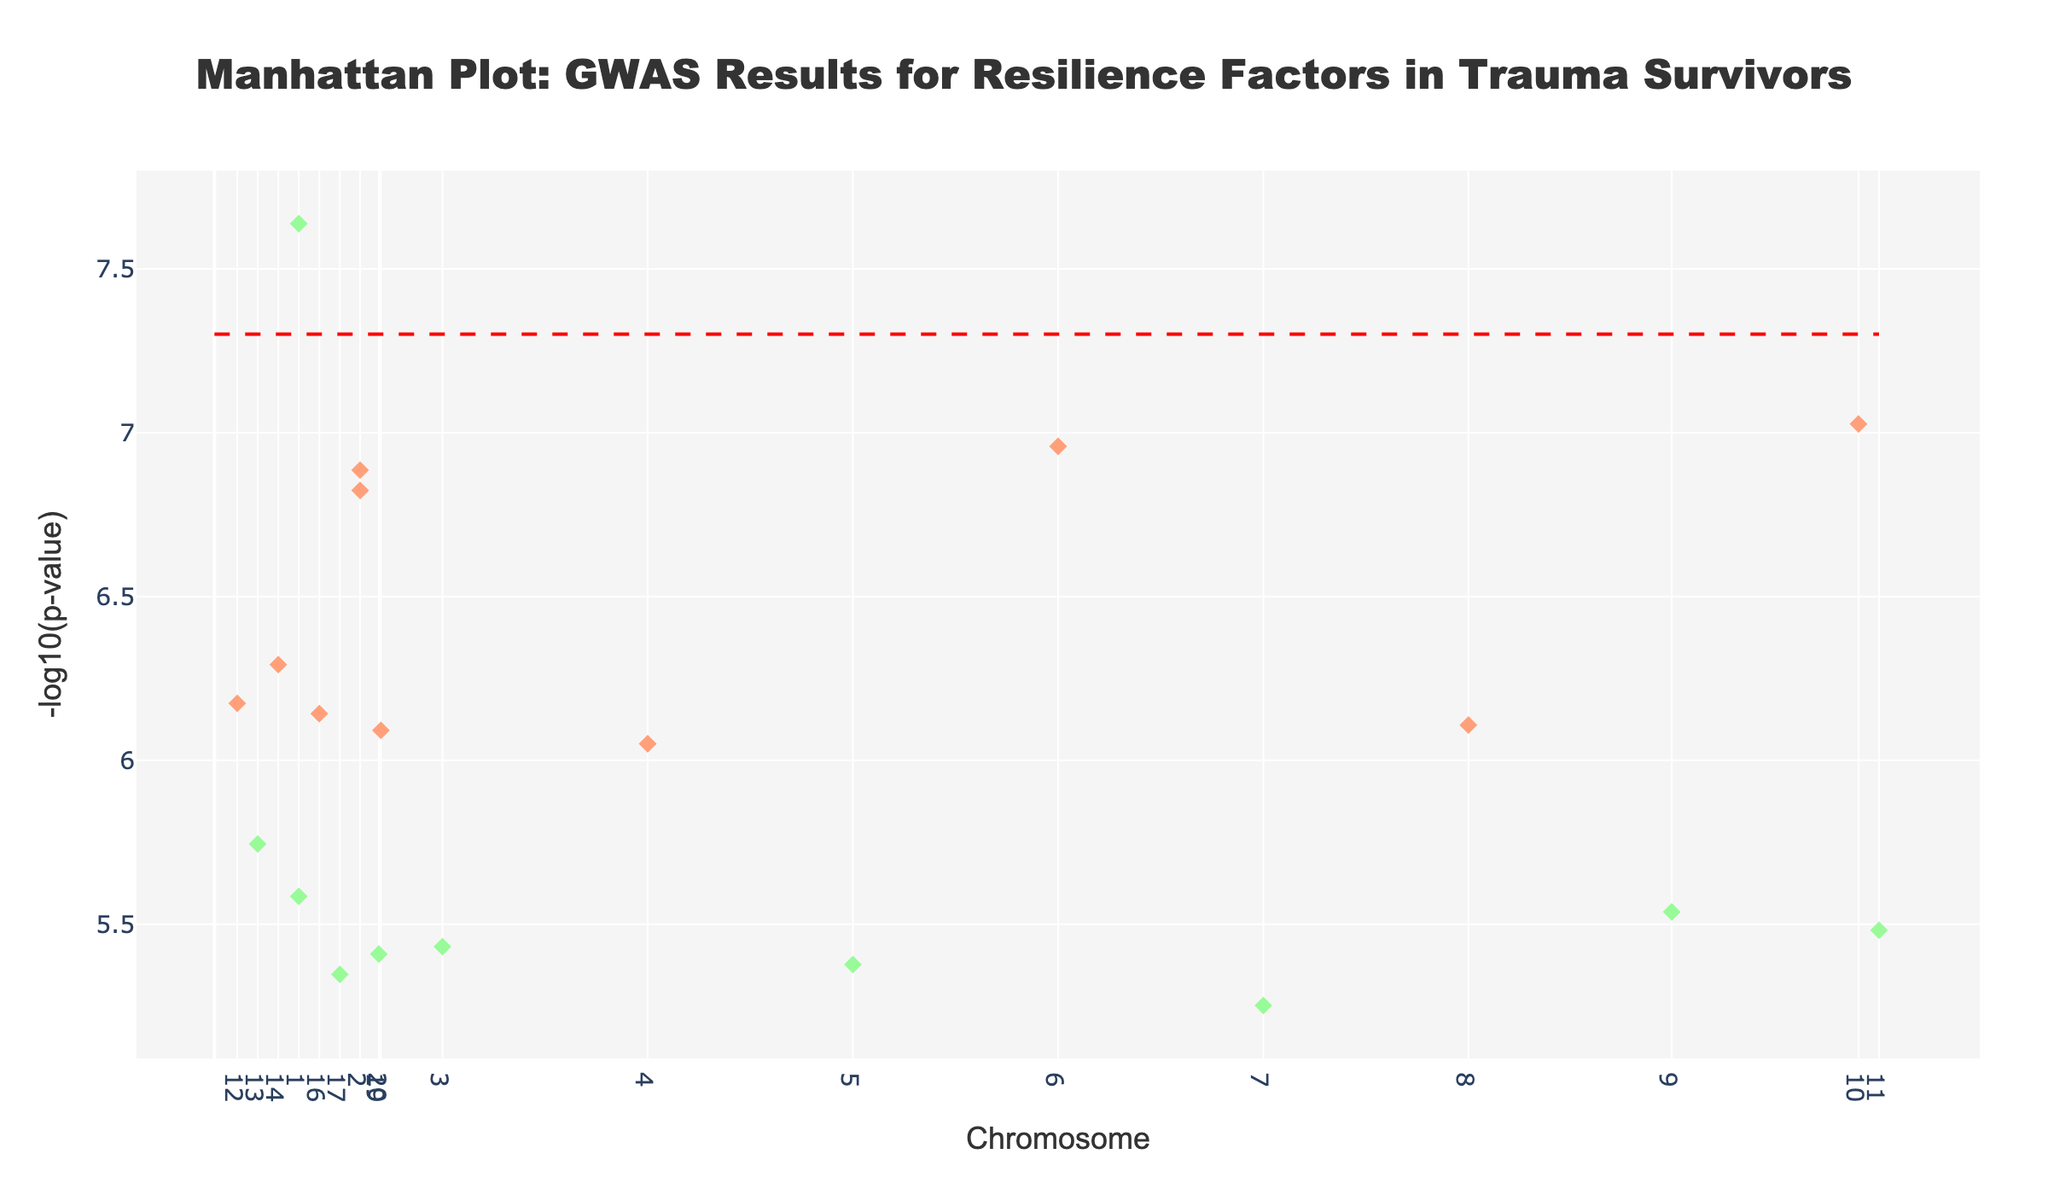What is the title of the plot? The title is displayed at the top center of the plot and is usually in a larger and bold font compared to other textual elements. It gives an overview of the plot's content.
Answer: Manhattan Plot: GWAS Results for Resilience Factors in Trauma Survivors How are the chromosomes differentiated in the plot? Chromosomes are differentiated by alternating colors. Each unique chromosome is represented by a different color, either light coral or pale green.
Answer: By alternating colors Which SNP has the lowest P-value? The SNP with the lowest P-value will have the highest -log10(p) value in the plot since -log10(p) transforms small P-values into larger values. Find the highest point on the Y-axis.
Answer: rs1234567 (on Chromosome 1, Gene FKBP5) What is the purpose of the red dashed line in the plot? The red dashed line represents a genome-wide significance threshold, typically set at -log10(5e-8). It helps to identify SNPs that are considered statistically significant.
Answer: Significance threshold line How many SNPs have a -log10(p) value greater than 5? Count the number of data points above the -log10(p-value) of 5 line. These are the SNPs considered highly significant.
Answer: Five SNPs (rs1234567 on Chromosome 1, rs0123456 on Chromosome 10, rs6789012 on Chromosome 6, rs8901234 on Chromosome 18, and rs2345678 on Chromosome 2) Which chromosome has the most SNPs with significant P-values? Identify the chromosome with the greatest number of markers above the red dashed significance line. The significance line helps us count only the relevant SNPs.
Answer: Chromosome 1 What’s the -log10(p) value for the SNP associated with the CACNA1C gene? Locate the SNP associated with CACNA1C in the plot and read its corresponding -log10(p) value on the Y-axis.
Answer: ~6.17 Which two chromosomes have the closest average P-value? Calculate the average P-value for SNPs on each chromosome and compare. Alternatively, visually approximate from the plot where -log10(p-values) of SNPs for different chromosomes cluster around the same value.
Answer: Chromosomes 3 and 5 Is there any pattern observed in the distribution of significant SNPs across different chromosomes? Observing the spread and clustering of SNPs, particularly those above the significance threshold, to see if significant SNPs are evenly distributed or if they cluster in certain chromosomes.
Answer: Significant SNPs tend to cluster in specific chromosomes How does the -log10(p) value for the gene BDNF compare to that of NPY? Locate the -log10(p) values for BDNF on Chromosome 3 and NPY on Chromosome 6 and compare their heights in the plot.
Answer: The -log10(p) value for NPY is higher than that for BDNF 